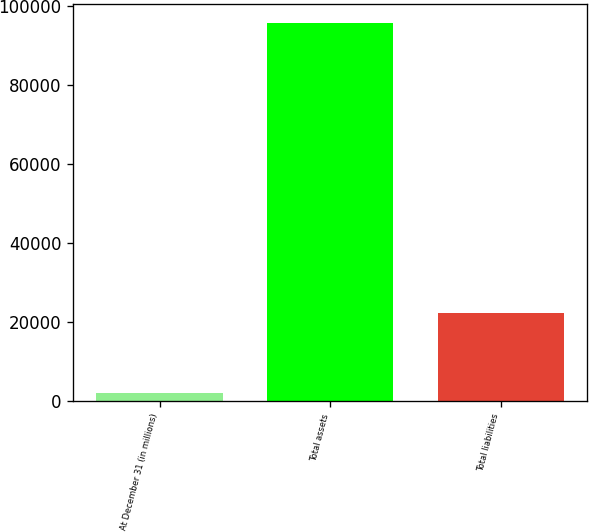Convert chart to OTSL. <chart><loc_0><loc_0><loc_500><loc_500><bar_chart><fcel>At December 31 (in millions)<fcel>Total assets<fcel>Total liabilities<nl><fcel>2011<fcel>95749<fcel>22379<nl></chart> 